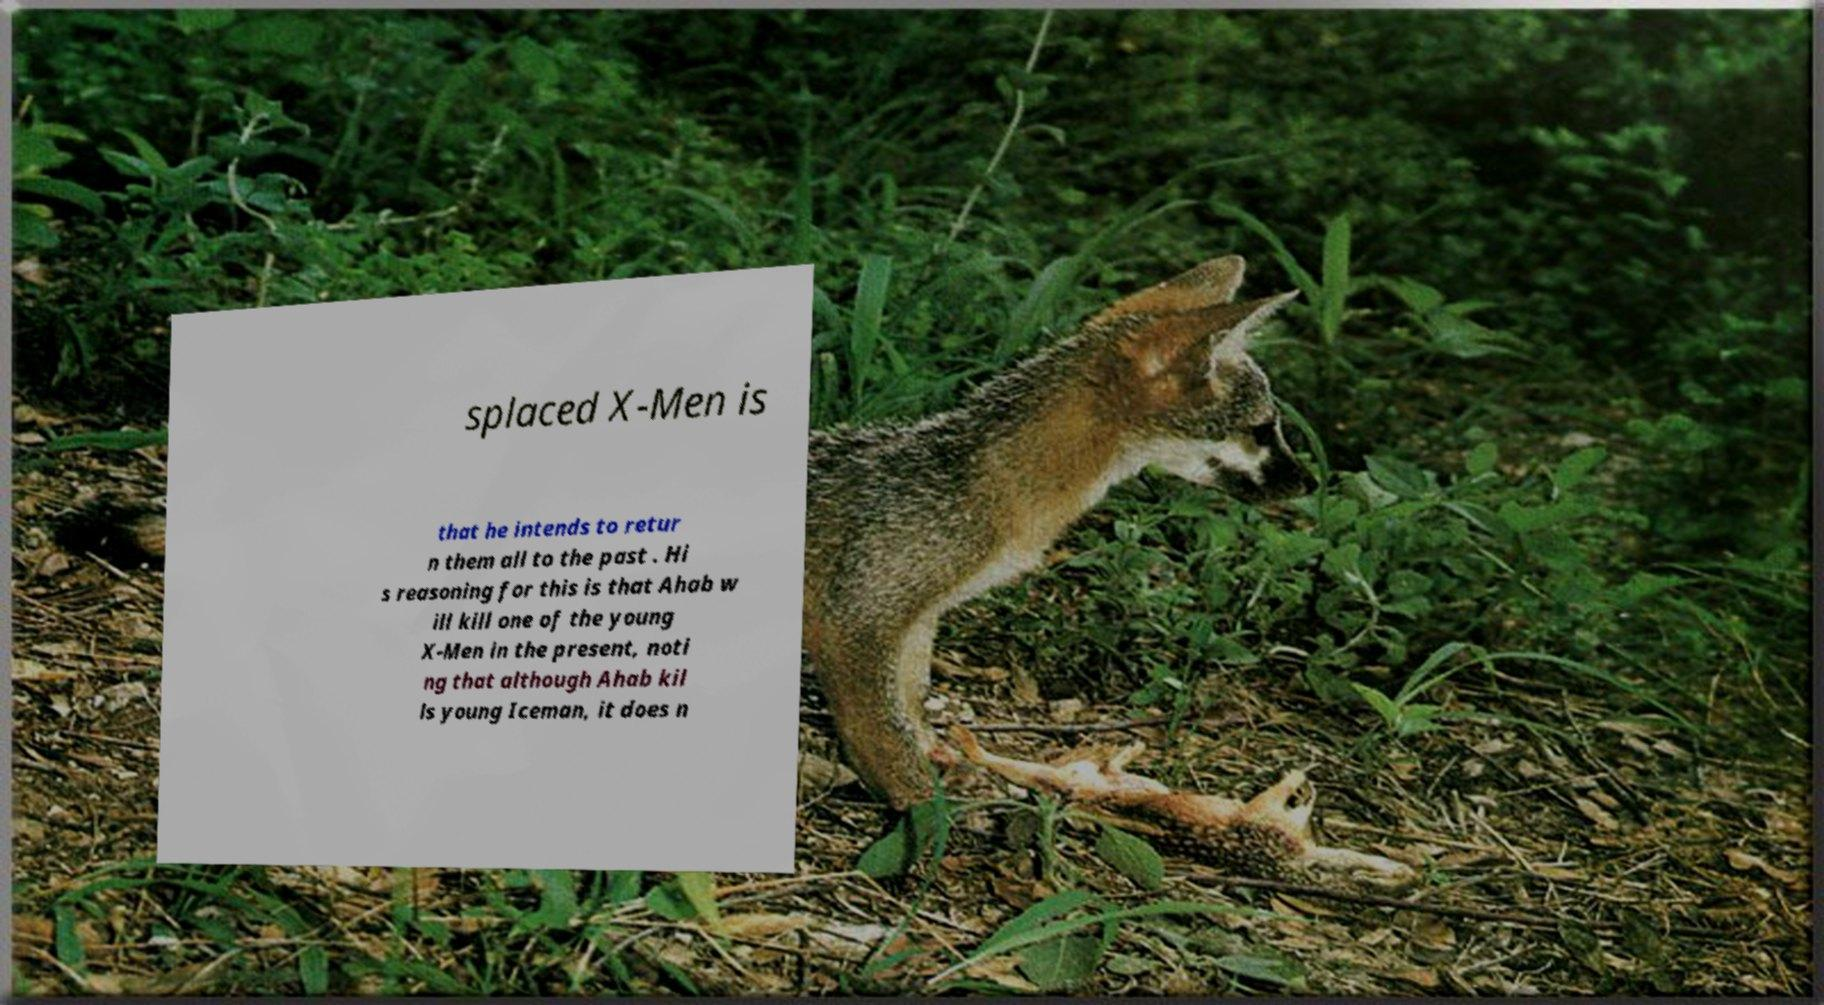There's text embedded in this image that I need extracted. Can you transcribe it verbatim? splaced X-Men is that he intends to retur n them all to the past . Hi s reasoning for this is that Ahab w ill kill one of the young X-Men in the present, noti ng that although Ahab kil ls young Iceman, it does n 